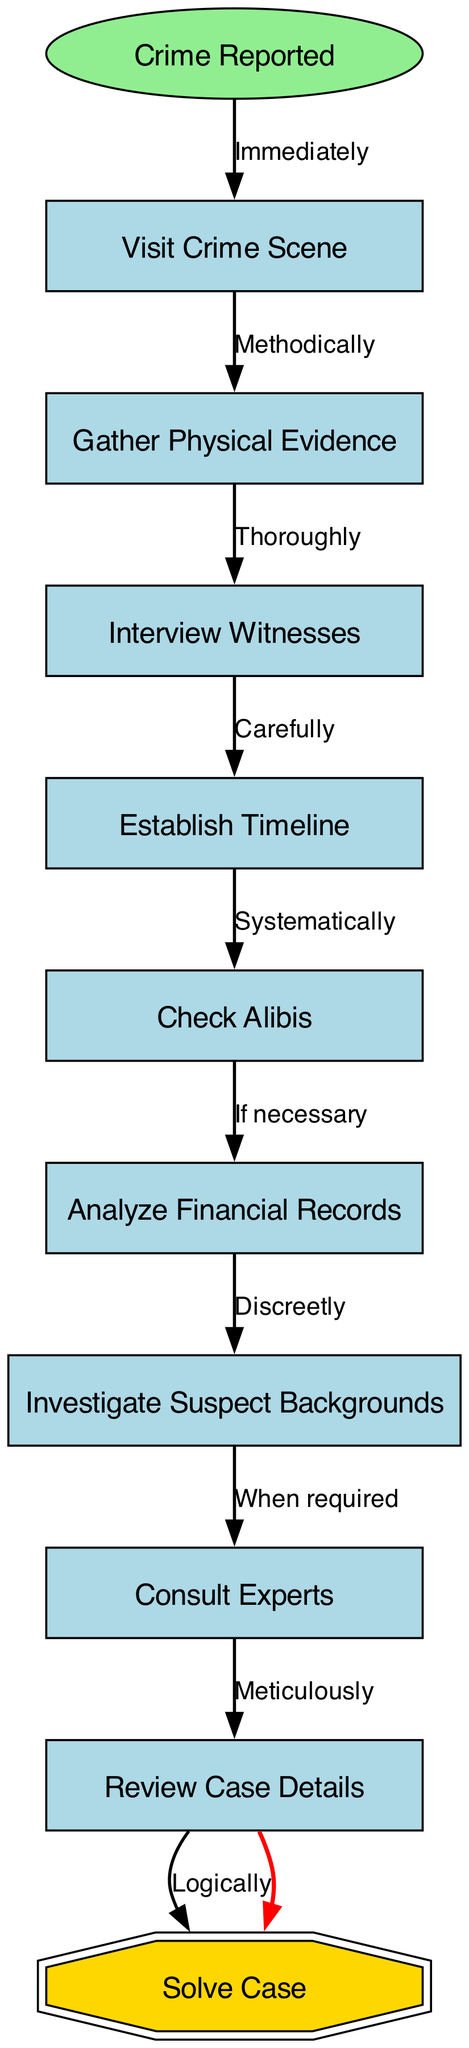What is the first step in Chief Inspector French's investigative process? The diagram starts with the node labeled "Crime Reported", which indicates the first action that triggers his investigative process.
Answer: Crime Reported How many nodes are present in the diagram? The diagram contains a total of 10 nodes, including the start node and all subsequent steps in Chief Inspector French's investigative process.
Answer: 10 What label connects "Gather Physical Evidence" and "Interview Witnesses"? The edge between "Gather Physical Evidence" and "Interview Witnesses" has the label "Thoroughly", indicating the manner in which this transition occurs in the investigative process.
Answer: Thoroughly Which step comes after "Establish Timeline"? The flowchart shows that the next step following "Establish Timeline" is "Check Alibis", as indicated by the directed edge connecting them in the diagram.
Answer: Check Alibis What is the final step in the investigative process as per the diagram? The last node in the sequence is "Solve Case", as indicated in the diagram, representing the culmination of the investigative efforts.
Answer: Solve Case What label is used for the edge between "Review Case Details" and "Solve Case"? The edge connecting "Review Case Details" to "Solve Case" is labeled "Logically", emphasizing the rationale in transitioning to solving the case.
Answer: Logically What is the relationship between "Consult Experts" and "Review Case Details"? The relationship is established by the edge labeled "Meticulously" that indicates the methodical approach Chief Inspector French employs while consulting experts before reviewing case details.
Answer: Meticulously If "Check Alibis" is negative, what is the next step? According to the diagram, if "Check Alibis" is negative, the process does not advance to "Analyze Financial Records" unless that step is deemed necessary, based on the conditioning presented in that edge.
Answer: Analyze Financial Records What unique shape does the final node "Solve Case" have? "Solve Case" is represented as a double octagon, a distinct shape that signifies the final outcome of Chief Inspector French's investigative process.
Answer: Double octagon 